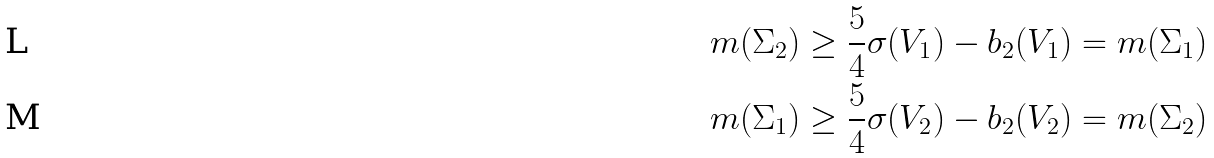Convert formula to latex. <formula><loc_0><loc_0><loc_500><loc_500>m ( \Sigma _ { 2 } ) \geq \frac { 5 } { 4 } \sigma ( V _ { 1 } ) - b _ { 2 } ( V _ { 1 } ) = m ( \Sigma _ { 1 } ) \\ m ( \Sigma _ { 1 } ) \geq \frac { 5 } { 4 } \sigma ( V _ { 2 } ) - b _ { 2 } ( V _ { 2 } ) = m ( \Sigma _ { 2 } )</formula> 